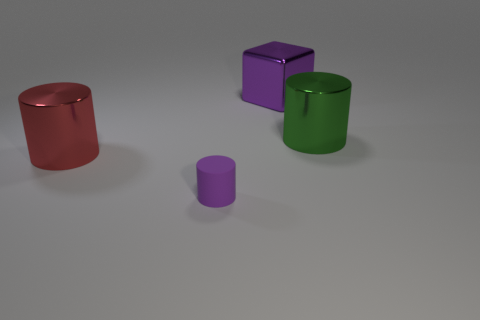There is a big thing that is the same color as the tiny rubber cylinder; what is its shape?
Your response must be concise. Cube. The cylinder that is the same color as the metal cube is what size?
Provide a short and direct response. Small. There is a object that is behind the big metal cylinder that is to the right of the big red metallic thing; what is it made of?
Ensure brevity in your answer.  Metal. Are there any large green shiny objects left of the green metal object?
Provide a short and direct response. No. Do the purple shiny block and the metal cylinder that is on the right side of the metallic block have the same size?
Your response must be concise. Yes. There is a purple object that is the same shape as the large red shiny object; what is its size?
Make the answer very short. Small. Is there anything else that has the same material as the red object?
Your response must be concise. Yes. Does the metallic object that is on the right side of the large purple shiny object have the same size as the purple thing in front of the big red metal thing?
Provide a succinct answer. No. What number of big things are either purple rubber cylinders or balls?
Your answer should be very brief. 0. How many shiny objects are in front of the large shiny cube and on the right side of the purple cylinder?
Provide a succinct answer. 1. 